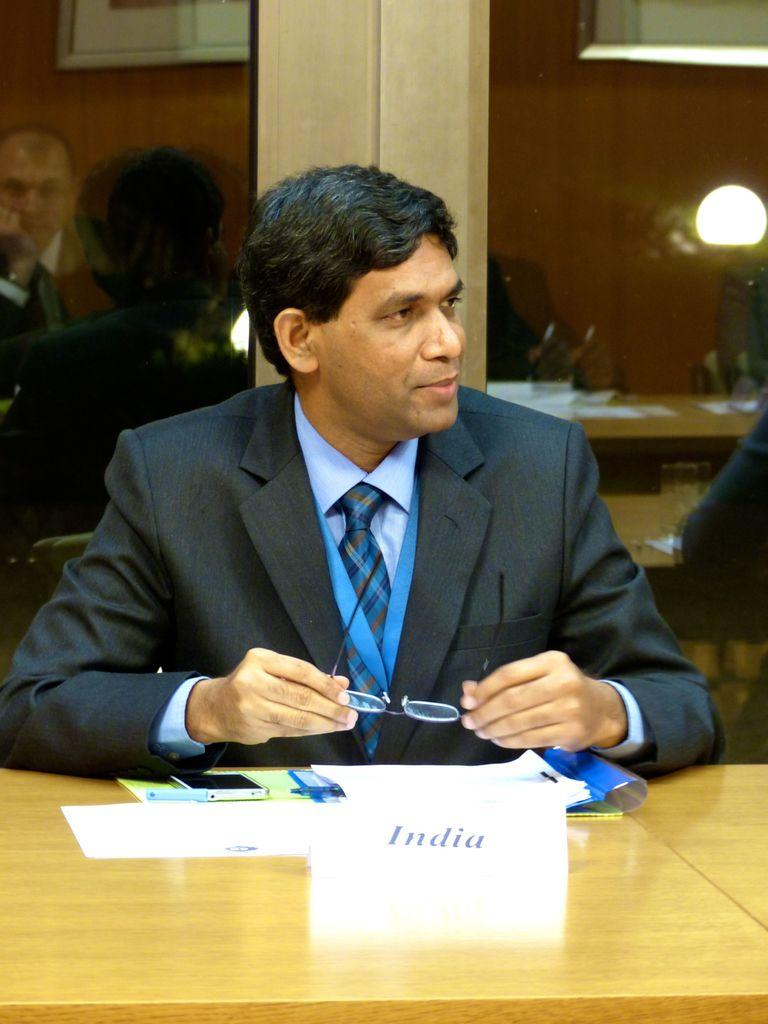What is the man in the image doing? The man is seated on a chair in the image. What is in front of the man? There is a name board in front of the man. What is on the table in the image? There is a mobile and papers on the table. What can be seen in the background of the image? There is a light in the background of the image. How many bikes are parked next to the man in the image? There are no bikes present in the image. Are the man's brothers also seated in the image? The provided facts do not mention any brothers, so we cannot assume their presence in the image. 